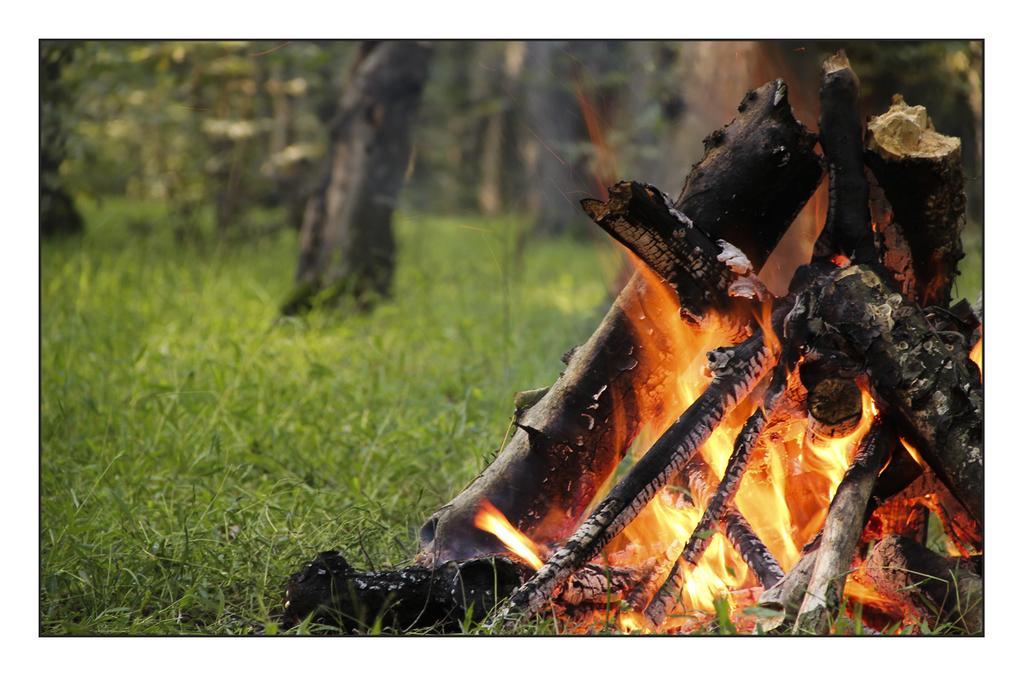Could you give a brief overview of what you see in this image? In this image there is the grass, there are trees truncated towards the top of the image, there is wood truncated towards the right of the image, there is fire. 